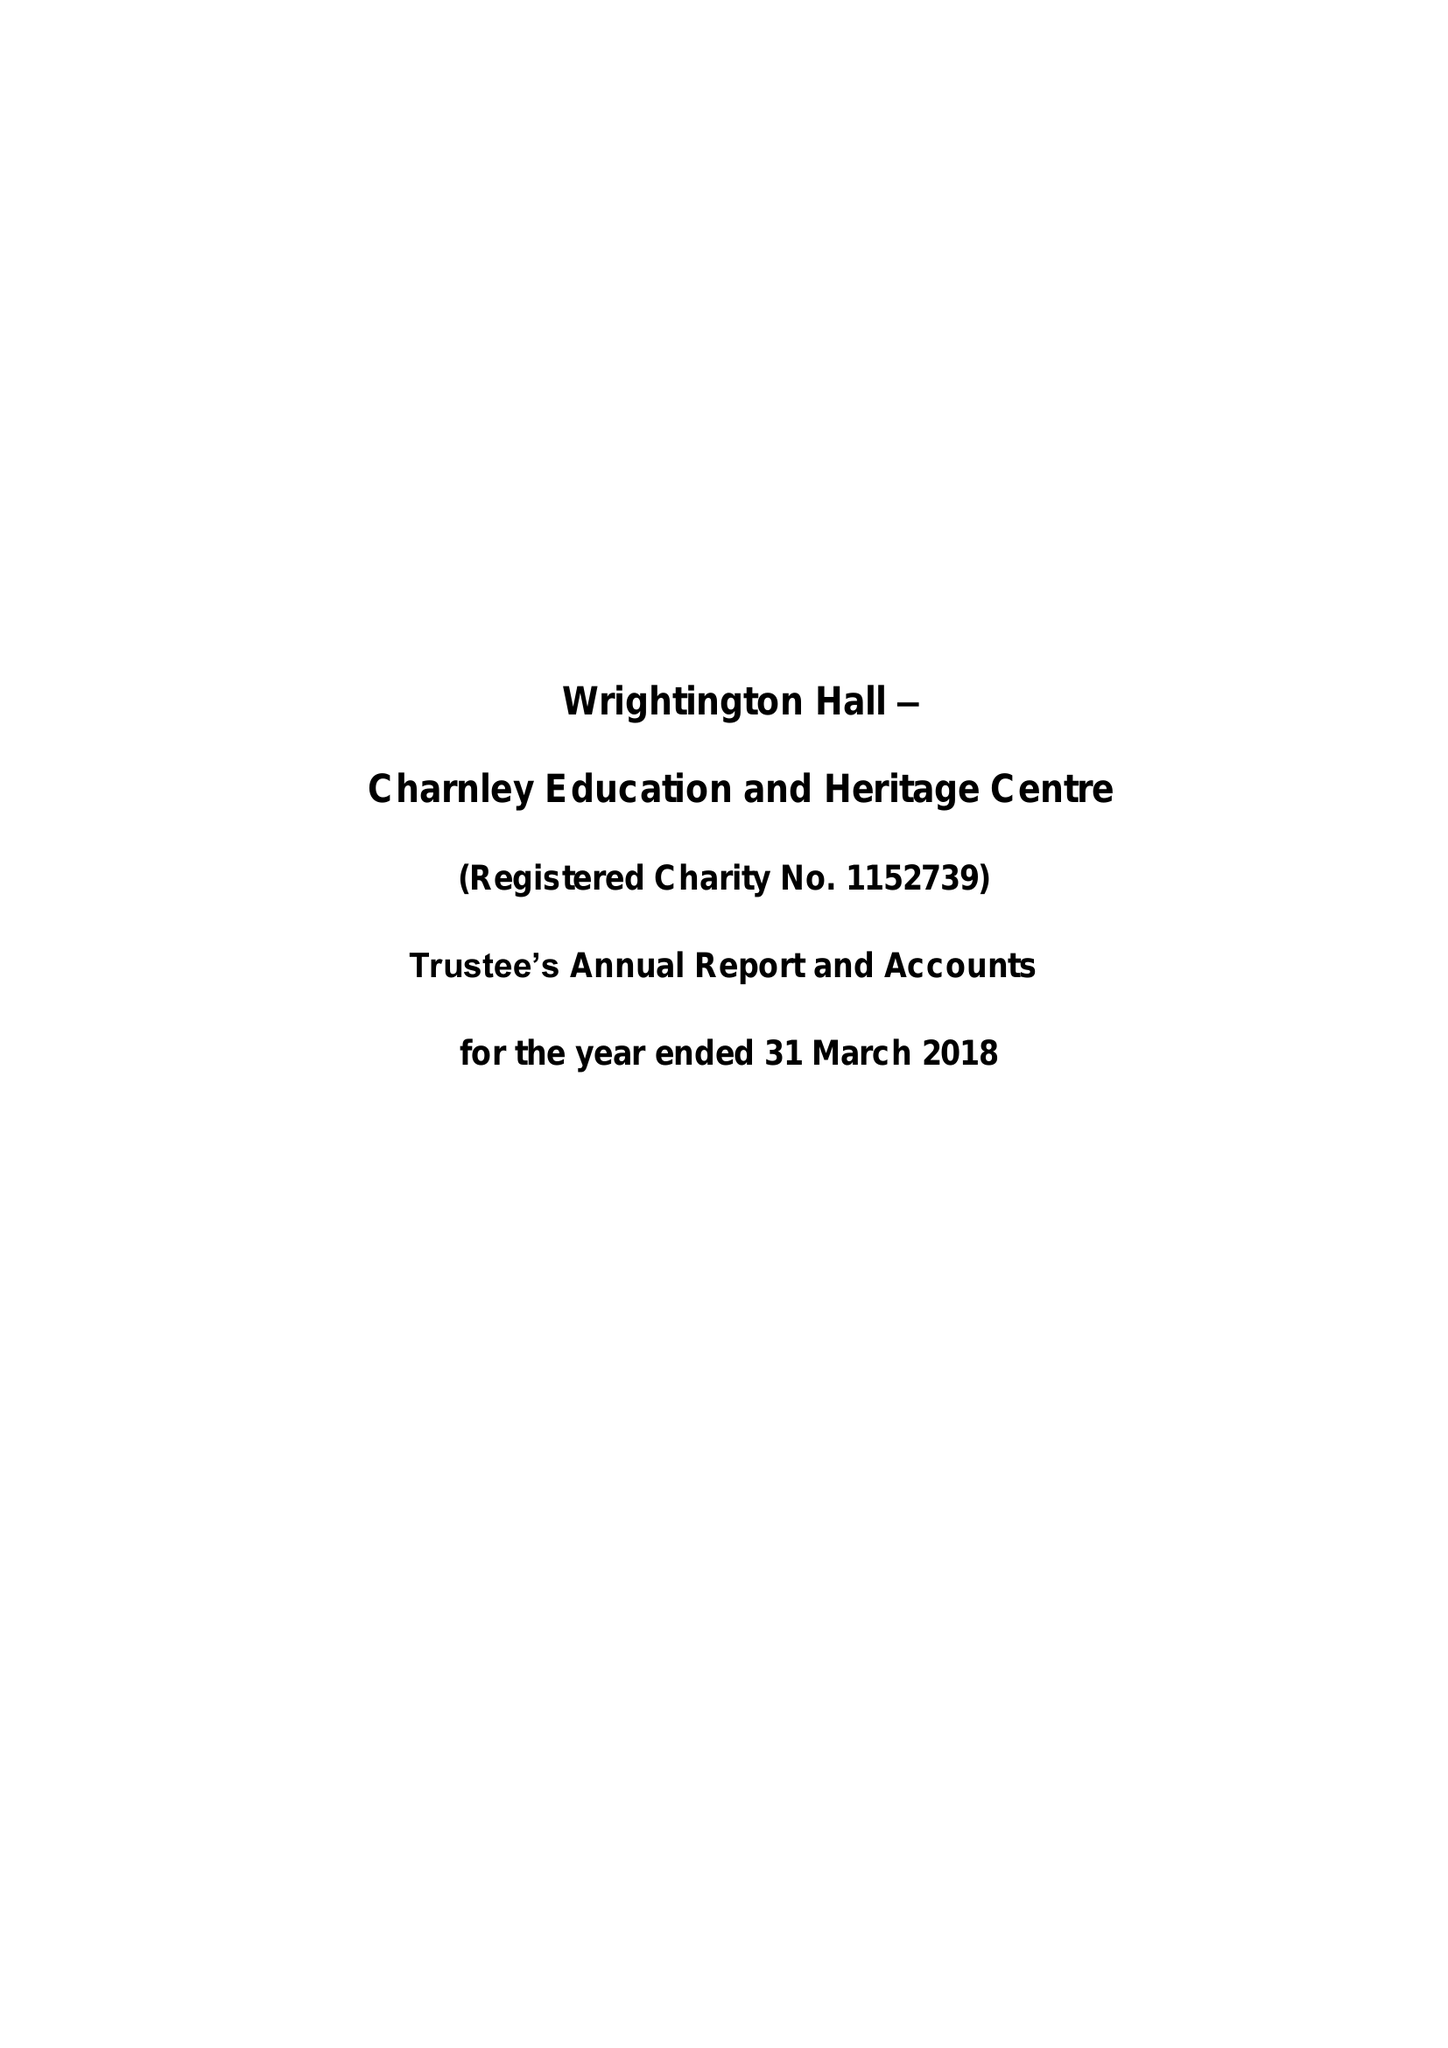What is the value for the income_annually_in_british_pounds?
Answer the question using a single word or phrase. None 